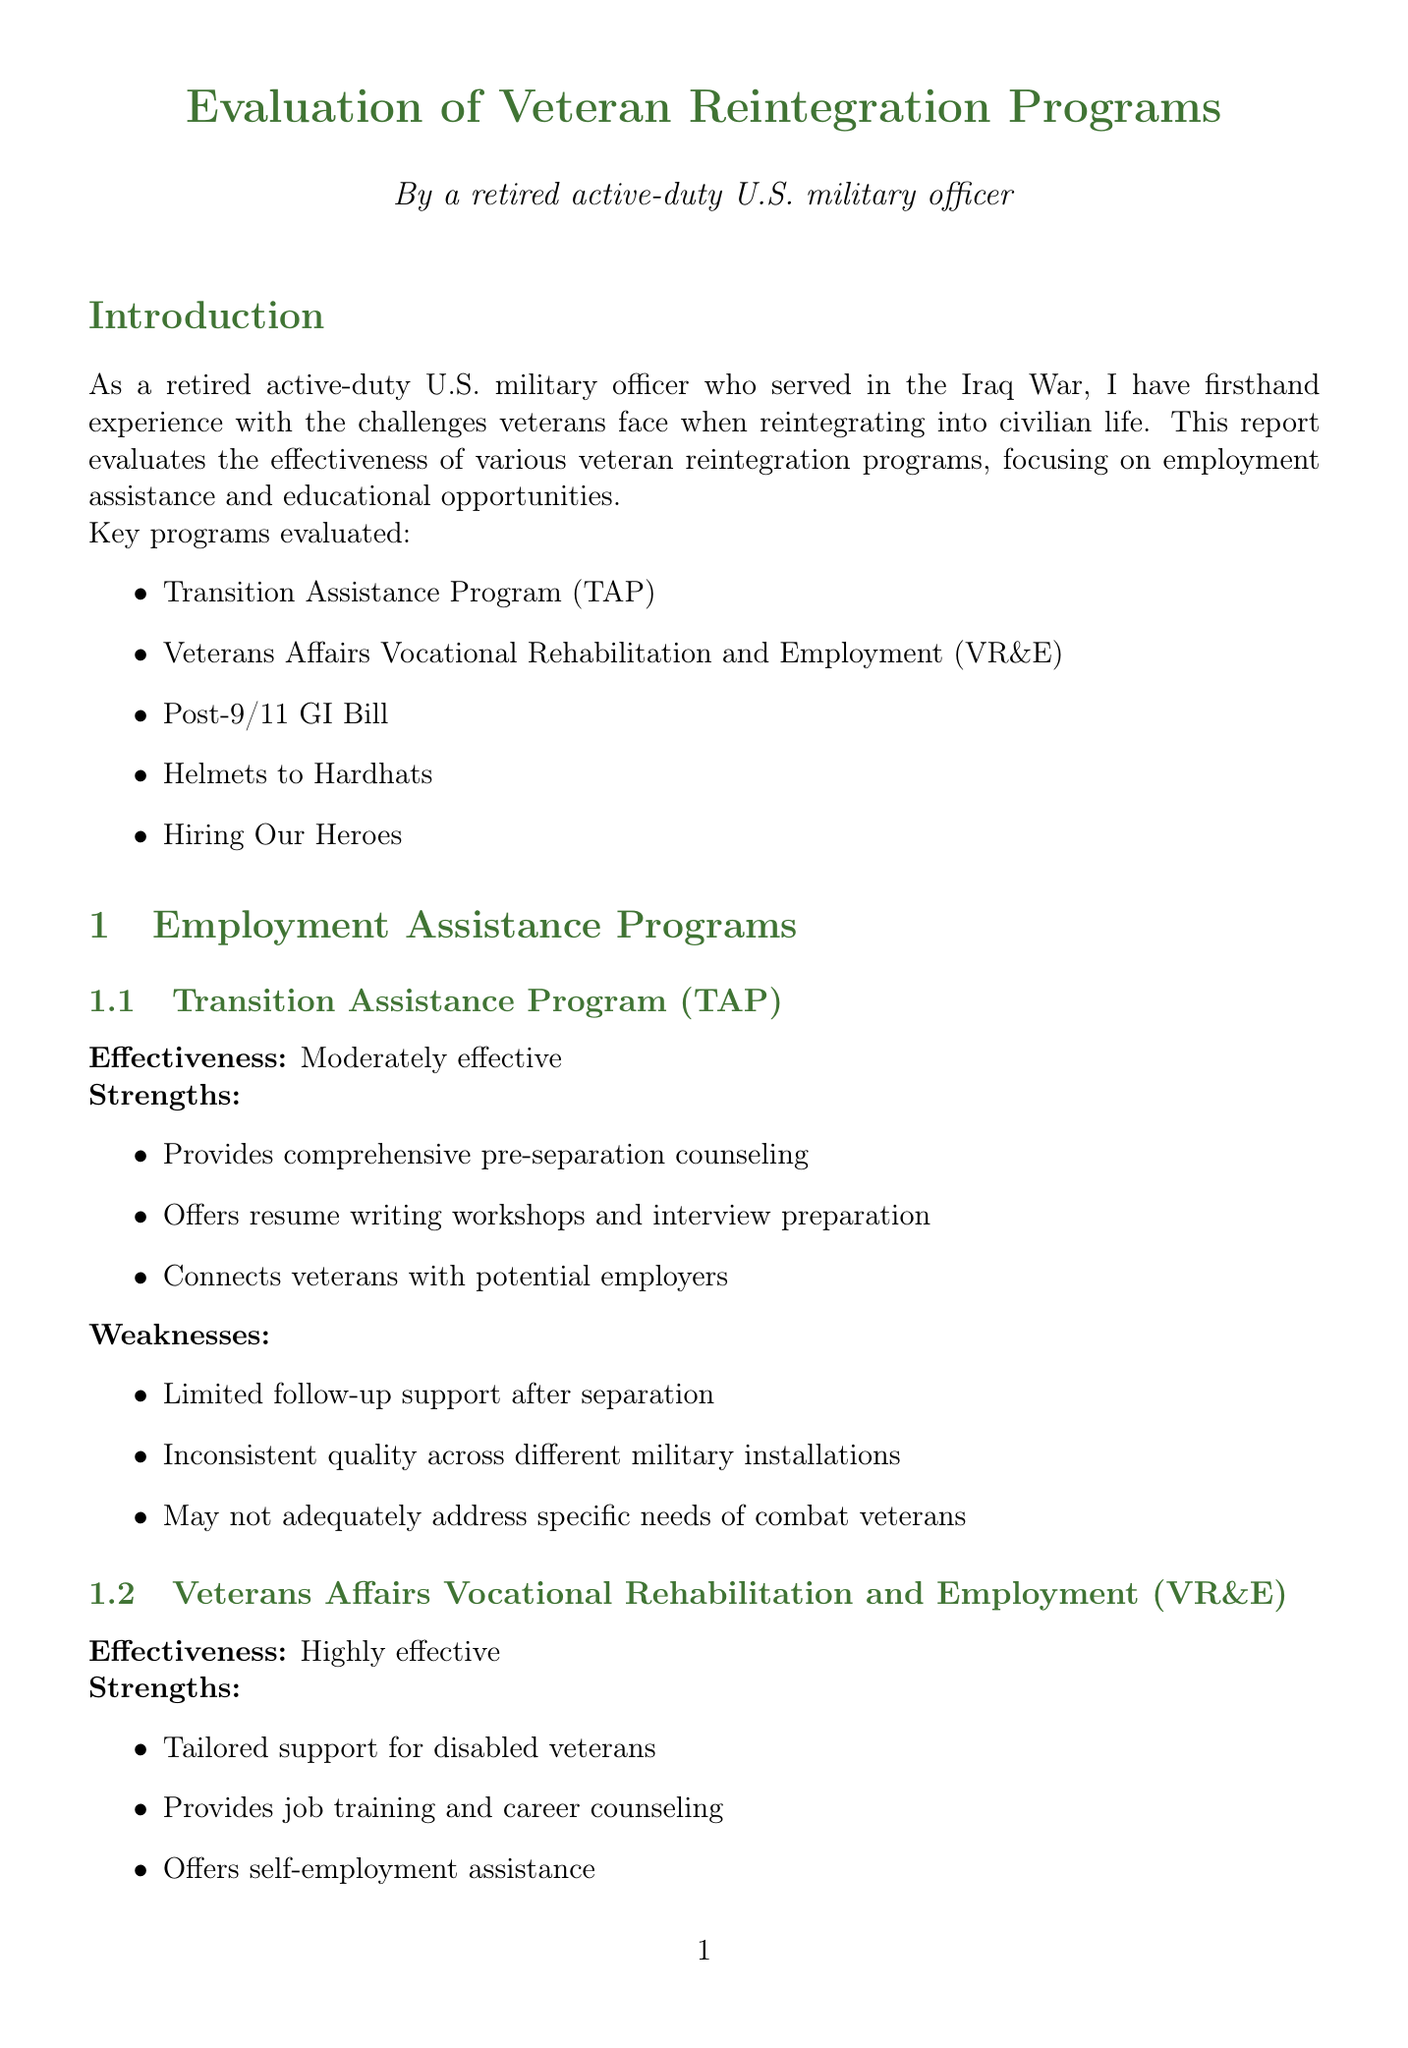What is the effectiveness rating of the Transition Assistance Program? The effectiveness rating is provided in the document under the section Employment Assistance Programs.
Answer: Moderately effective Which program is tailored for disabled veterans? This program is mentioned in the Employment Assistance Programs section as providing specialized support to a specific group of veterans.
Answer: Veterans Affairs Vocational Rehabilitation and Employment (VR&E) What does the Post-9/11 GI Bill cover? This is described in the Educational Opportunities section, outlining the benefits provided to veterans under this program.
Answer: Full tuition and fees at public universities What is a key weakness of the Hiring Our Heroes program? The document lists weaknesses for each program and mentions some challenges specific to the Hiring Our Heroes program.
Answer: Limited reach in rural areas Who is John Martinez? This is detailed in the Case Studies section, where specific individuals and their background information is provided.
Answer: Former Marine Corps Sergeant, served two tours in Iraq How many recommendations are included in the report? The recommendations are listed at the end of the document.
Answer: Five What is one suggested improvement for reintegration programs? This is found in the Recommendations section, focusing on actions to enhance the effectiveness of these programs.
Answer: Increase funding for mental health support What role did Sarah Thompson transition into? The outcome for Sarah Thompson is mentioned in the Case Studies section, highlighting her job after using the programs.
Answer: Management role at Boeing 